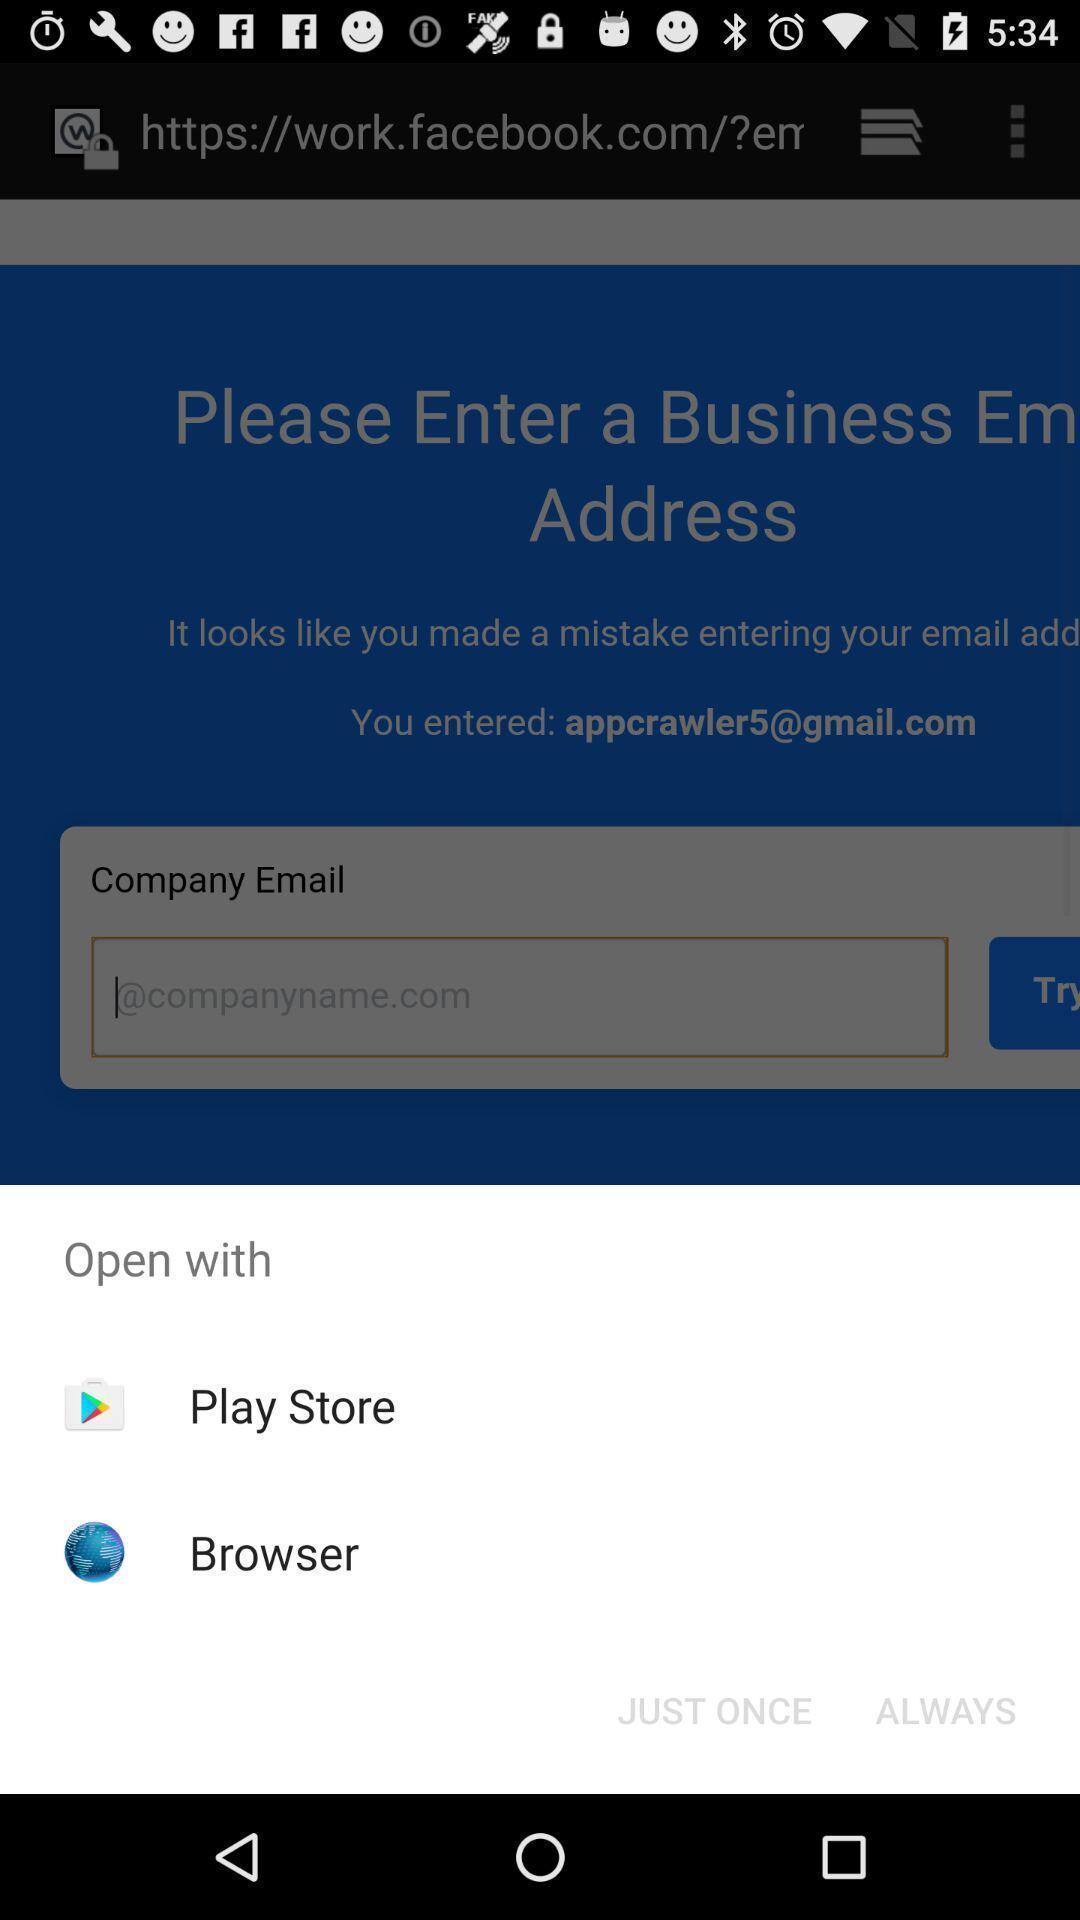Provide a detailed account of this screenshot. Popup of apps to browse the net. 